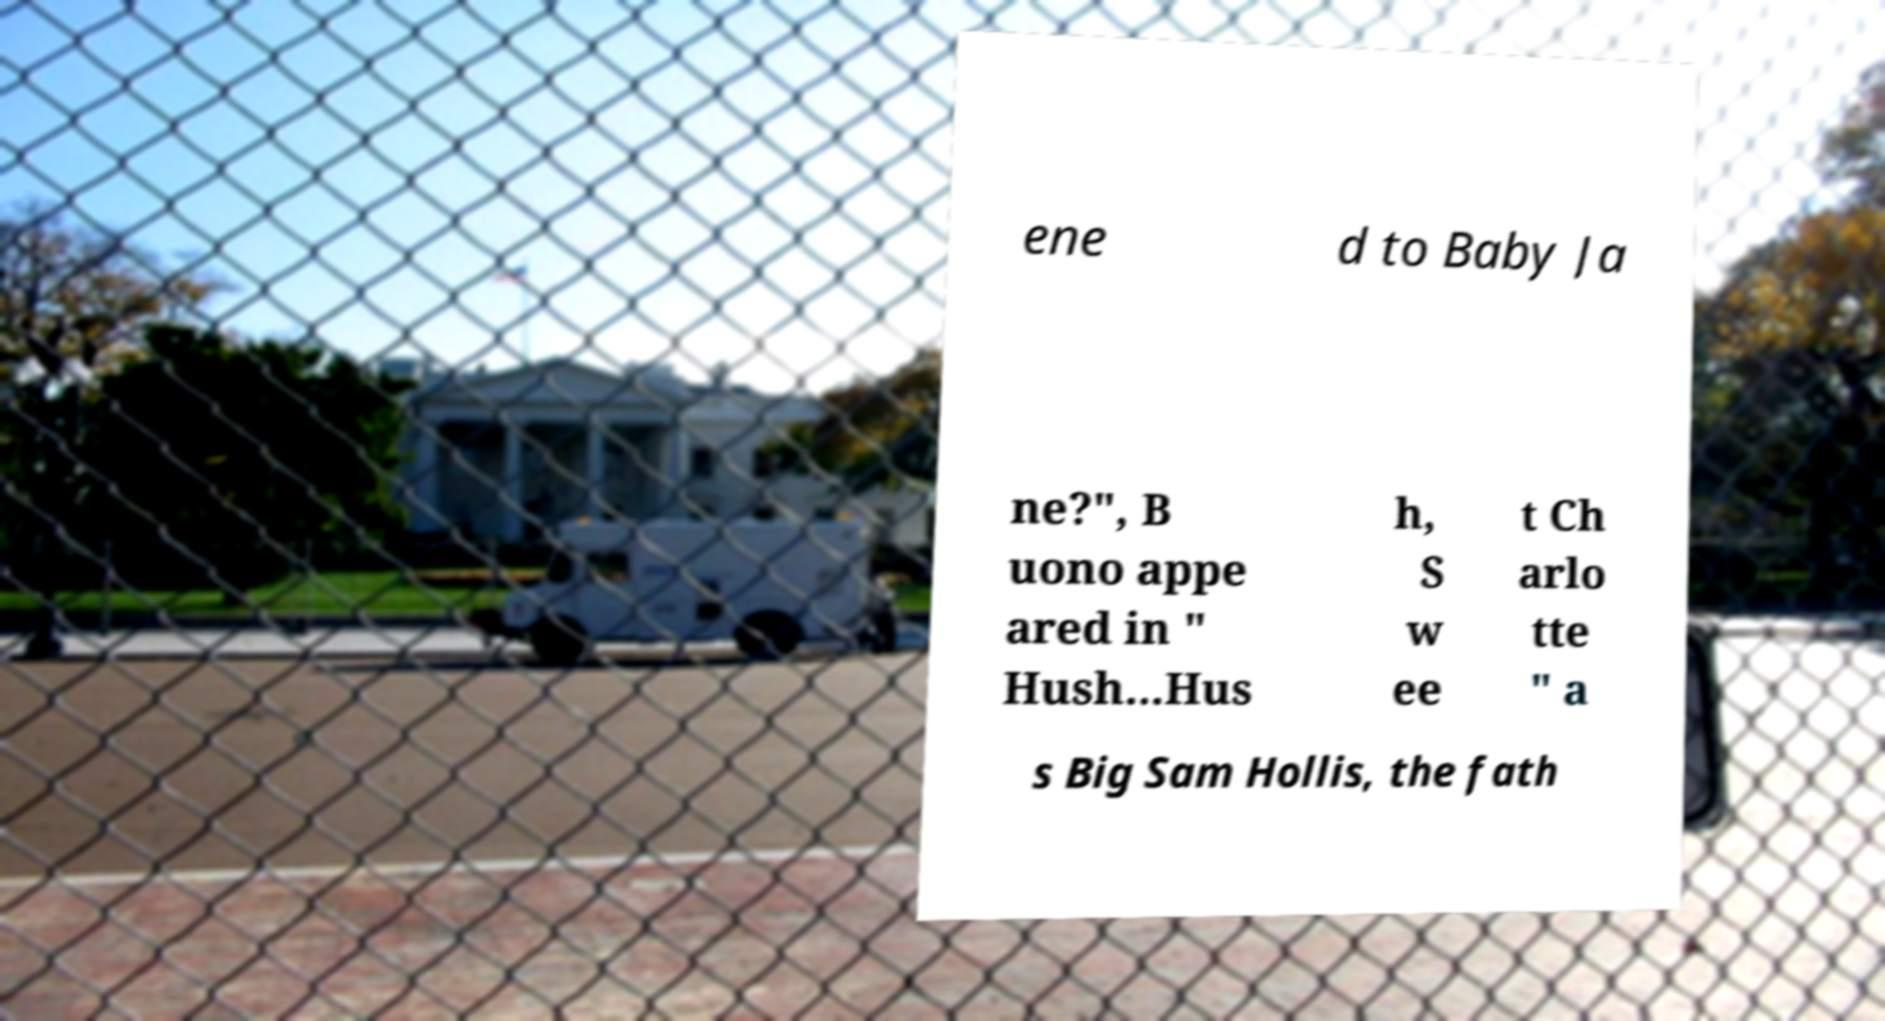For documentation purposes, I need the text within this image transcribed. Could you provide that? ene d to Baby Ja ne?", B uono appe ared in " Hush...Hus h, S w ee t Ch arlo tte " a s Big Sam Hollis, the fath 